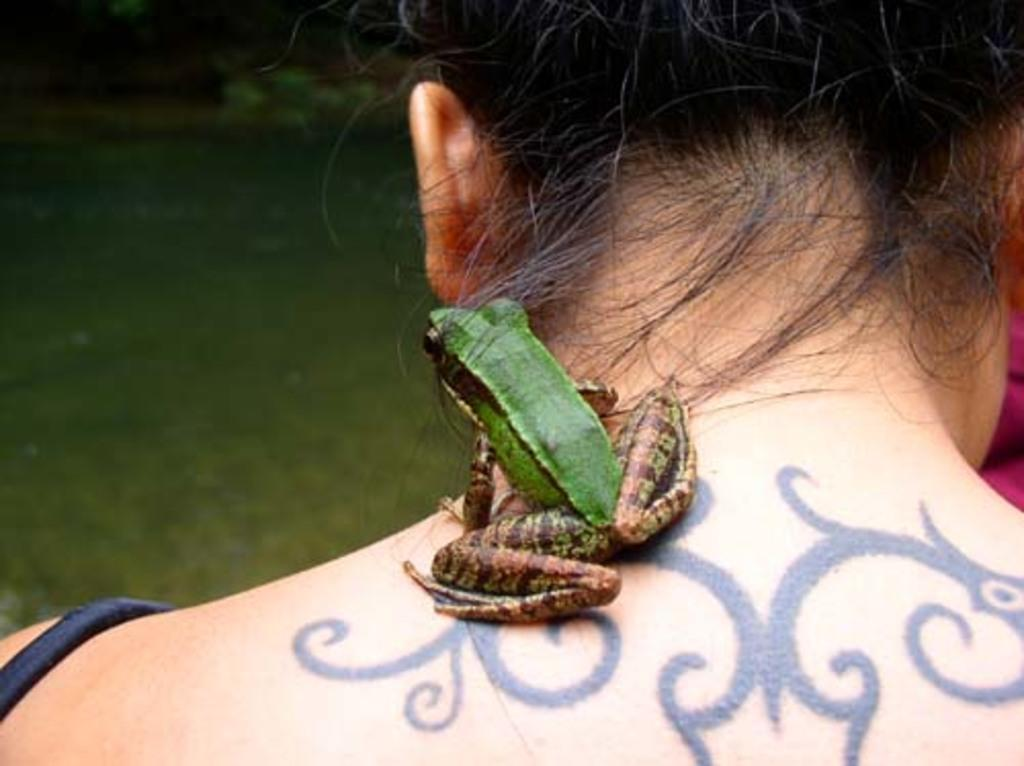What type of animal can be seen in the image? There is a frog in the image. What other detail can be observed about a person in the image? There is a tattoo on a woman's neck in the image. What can be seen in the background of the image? The ground is visible in the background of the image. How does the frog claim its territory in the image? The image does not show the frog claiming its territory, as it is not a behavior typically associated with frogs. 